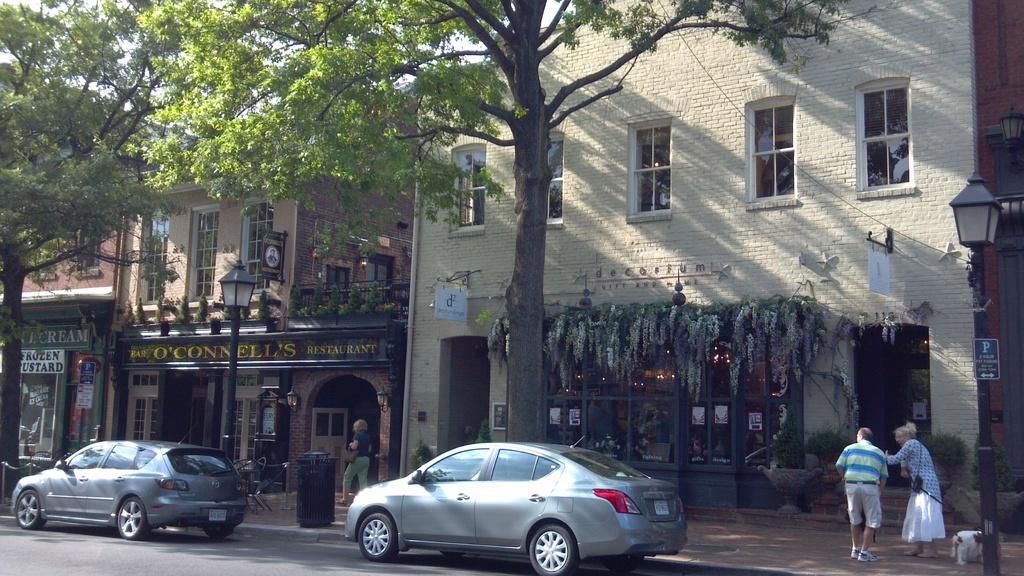In one or two sentences, can you explain what this image depicts? In the picture I can see two cars on the road and there are few stores and trees beside it and there is a light attached to a pole,two persons and a dog in the right corner. 